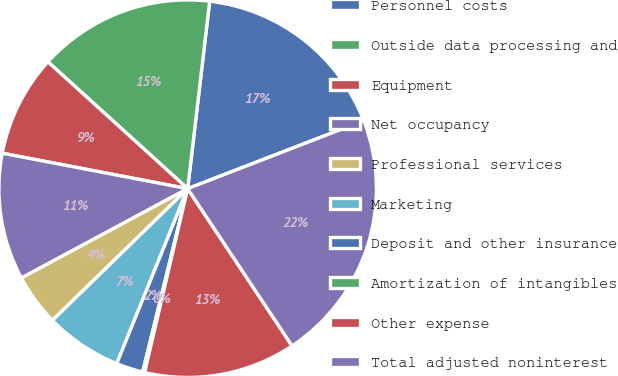Convert chart to OTSL. <chart><loc_0><loc_0><loc_500><loc_500><pie_chart><fcel>Personnel costs<fcel>Outside data processing and<fcel>Equipment<fcel>Net occupancy<fcel>Professional services<fcel>Marketing<fcel>Deposit and other insurance<fcel>Amortization of intangibles<fcel>Other expense<fcel>Total adjusted noninterest<nl><fcel>17.27%<fcel>15.13%<fcel>8.72%<fcel>10.86%<fcel>4.44%<fcel>6.58%<fcel>2.3%<fcel>0.17%<fcel>12.99%<fcel>21.54%<nl></chart> 